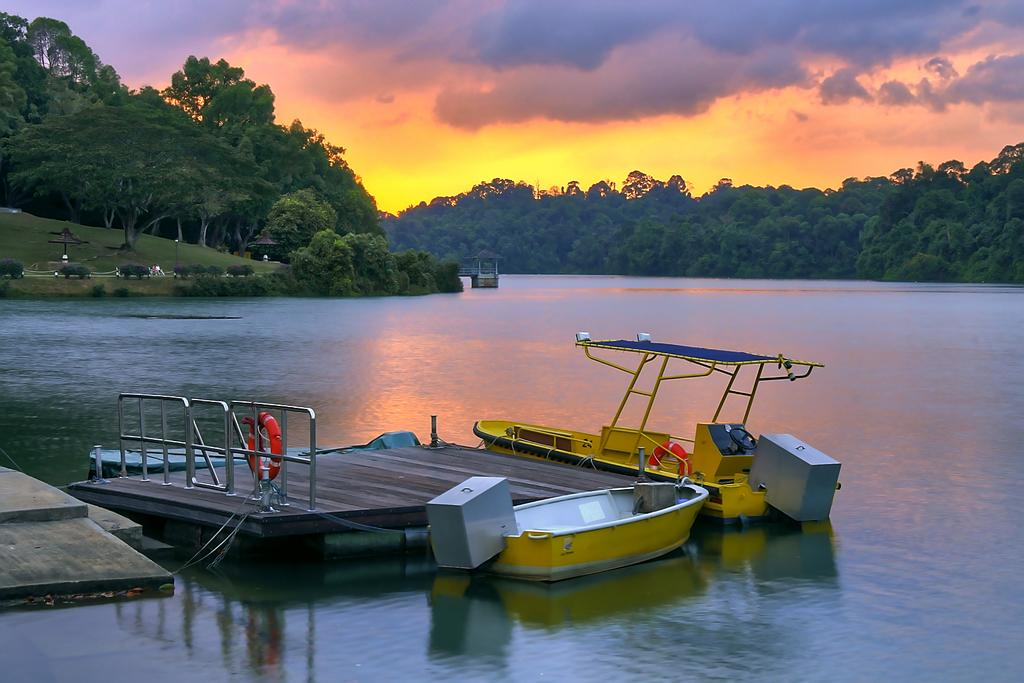What type of water body is present in the image? There is a river in the image. What is floating on the water in the image? There are yellow boats floating on the water. What can be seen in the background of the image? There are trees in the background of the image. What is visible in the sky in the image? The sky is visible in the image, and there are clouds in the sky. How many marbles are floating on the river in the image? There are no marbles present in the image; only yellow boats are floating on the water. 